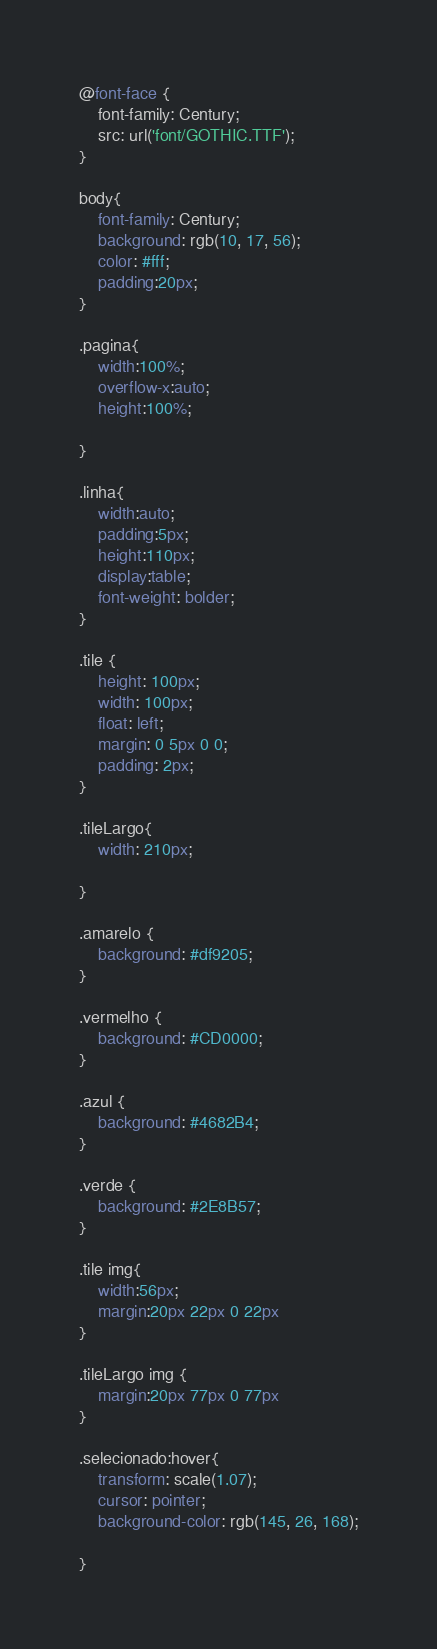Convert code to text. <code><loc_0><loc_0><loc_500><loc_500><_CSS_>@font-face {
    font-family: Century;
    src: url('font/GOTHIC.TTF');
}

body{
    font-family: Century;
    background: rgb(10, 17, 56);
    color: #fff;
    padding:20px;
}

.pagina{
    width:100%;
    overflow-x:auto;
    height:100%;
    
}

.linha{
    width:auto;
    padding:5px;
    height:110px;
    display:table;
    font-weight: bolder;
}

.tile {
    height: 100px;
    width: 100px;
    float: left;
    margin: 0 5px 0 0;
    padding: 2px;
}

.tileLargo{
    width: 210px;
    
}

.amarelo {
    background: #df9205;
}

.vermelho {
    background: #CD0000;
}

.azul {
    background: #4682B4;
}

.verde {
    background: #2E8B57;
}

.tile img{
    width:56px;
    margin:20px 22px 0 22px   
}

.tileLargo img {
    margin:20px 77px 0 77px
}

.selecionado:hover{
    transform: scale(1.07);
    cursor: pointer;
    background-color: rgb(145, 26, 168);
    
}


</code> 